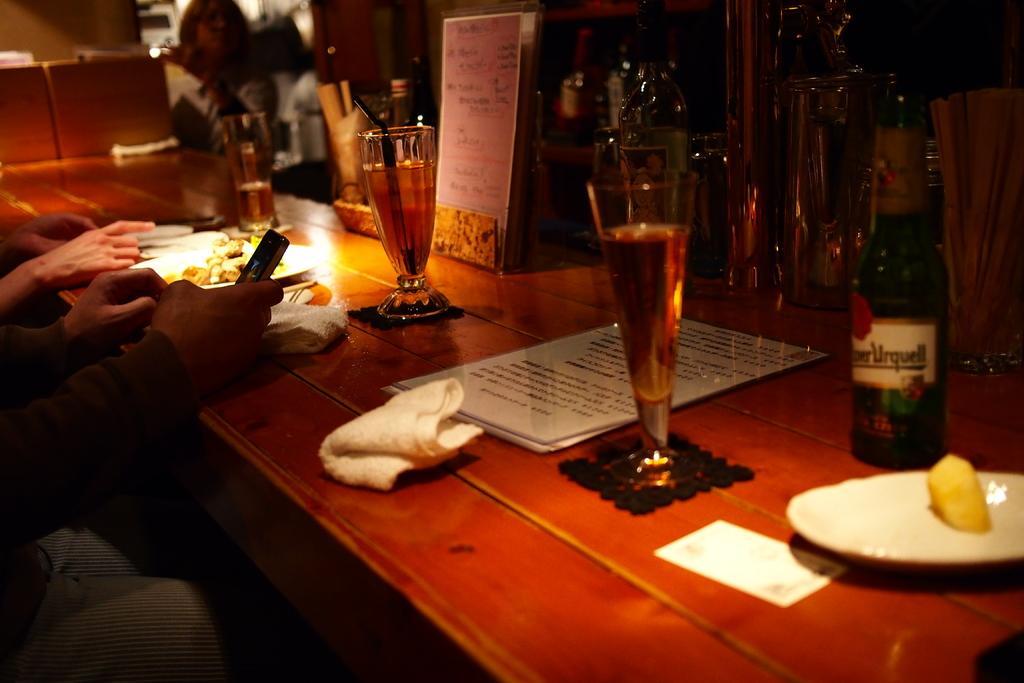In one or two sentences, can you explain what this image depicts? This picture describes about group of people, in front of them we can see bottle, glasses, menu card and plates on the table. 